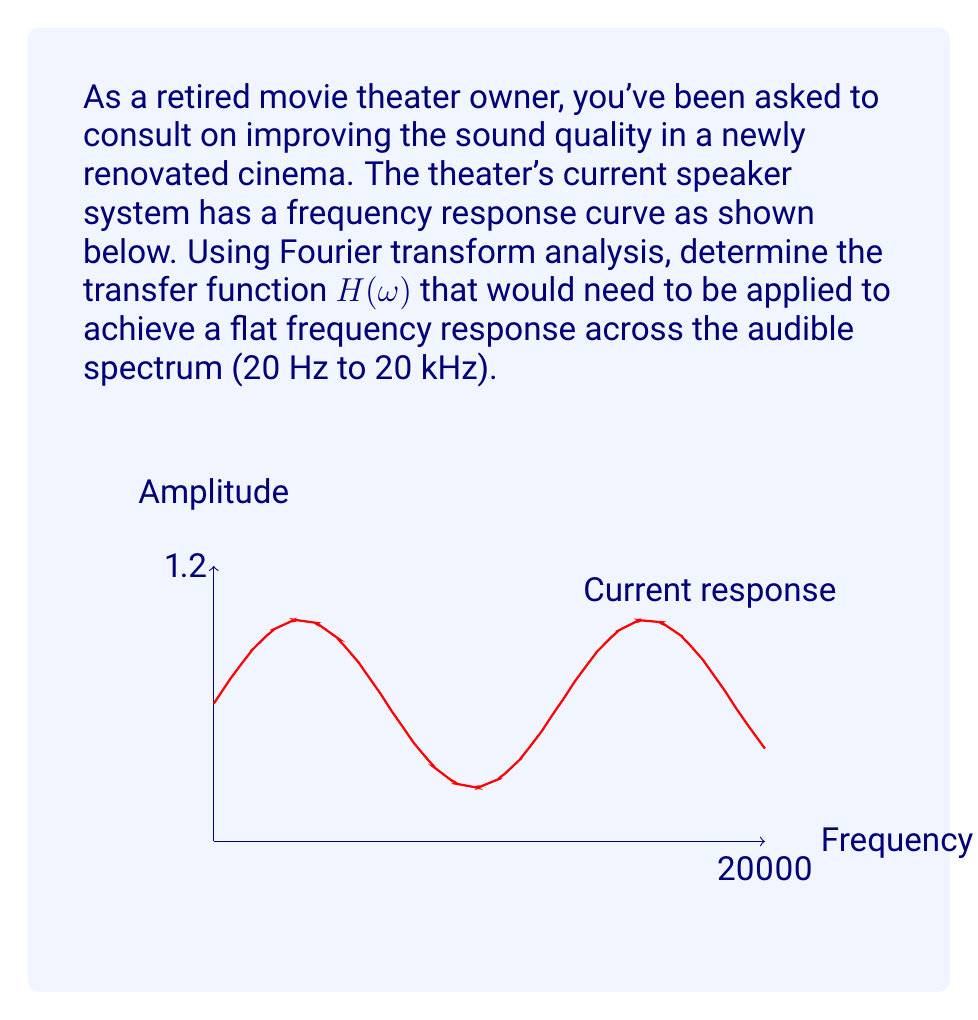Can you answer this question? To solve this problem, we'll follow these steps:

1) The current frequency response curve can be approximated by the function:

   $$A(\omega) = 0.5 + 0.5\sin(\frac{\omega}{1000})$$

   where $\omega$ is the angular frequency in radians per second.

2) We want to achieve a flat response, which can be represented as:

   $$A_{desired}(\omega) = 1$$

3) The transfer function $H(\omega)$ that we need to apply is the ratio of the desired response to the current response:

   $$H(\omega) = \frac{A_{desired}(\omega)}{A(\omega)} = \frac{1}{0.5 + 0.5\sin(\frac{\omega}{1000})}$$

4) To simplify this expression, we can use the trigonometric identity:

   $$\frac{1}{a + b\sin(x)} = \frac{1}{a}\cdot\frac{1}{1 + \frac{b}{a}\sin(x)}$$

   where $a = 0.5$ and $b = 0.5$

5) Applying this identity:

   $$H(\omega) = 2 \cdot \frac{1}{1 + \sin(\frac{\omega}{1000})}$$

6) This transfer function, when applied to the current system, will result in a flat frequency response across the audible spectrum.
Answer: $$H(\omega) = 2 \cdot \frac{1}{1 + \sin(\frac{\omega}{1000})}$$ 